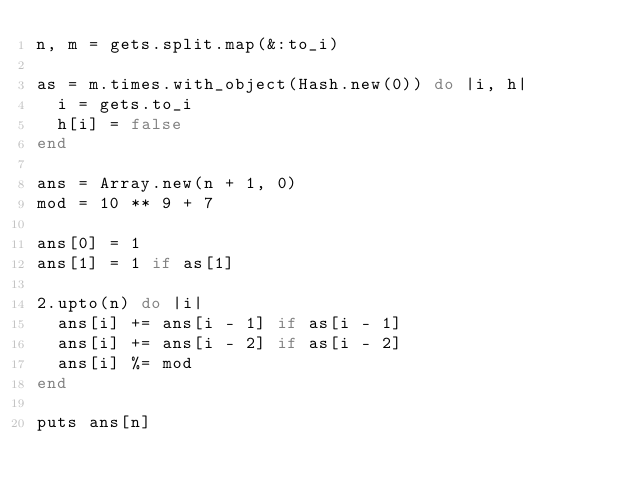Convert code to text. <code><loc_0><loc_0><loc_500><loc_500><_Ruby_>n, m = gets.split.map(&:to_i)

as = m.times.with_object(Hash.new(0)) do |i, h|
  i = gets.to_i
  h[i] = false
end

ans = Array.new(n + 1, 0)
mod = 10 ** 9 + 7

ans[0] = 1
ans[1] = 1 if as[1]

2.upto(n) do |i|
  ans[i] += ans[i - 1] if as[i - 1]
  ans[i] += ans[i - 2] if as[i - 2]
  ans[i] %= mod
end

puts ans[n]
</code> 